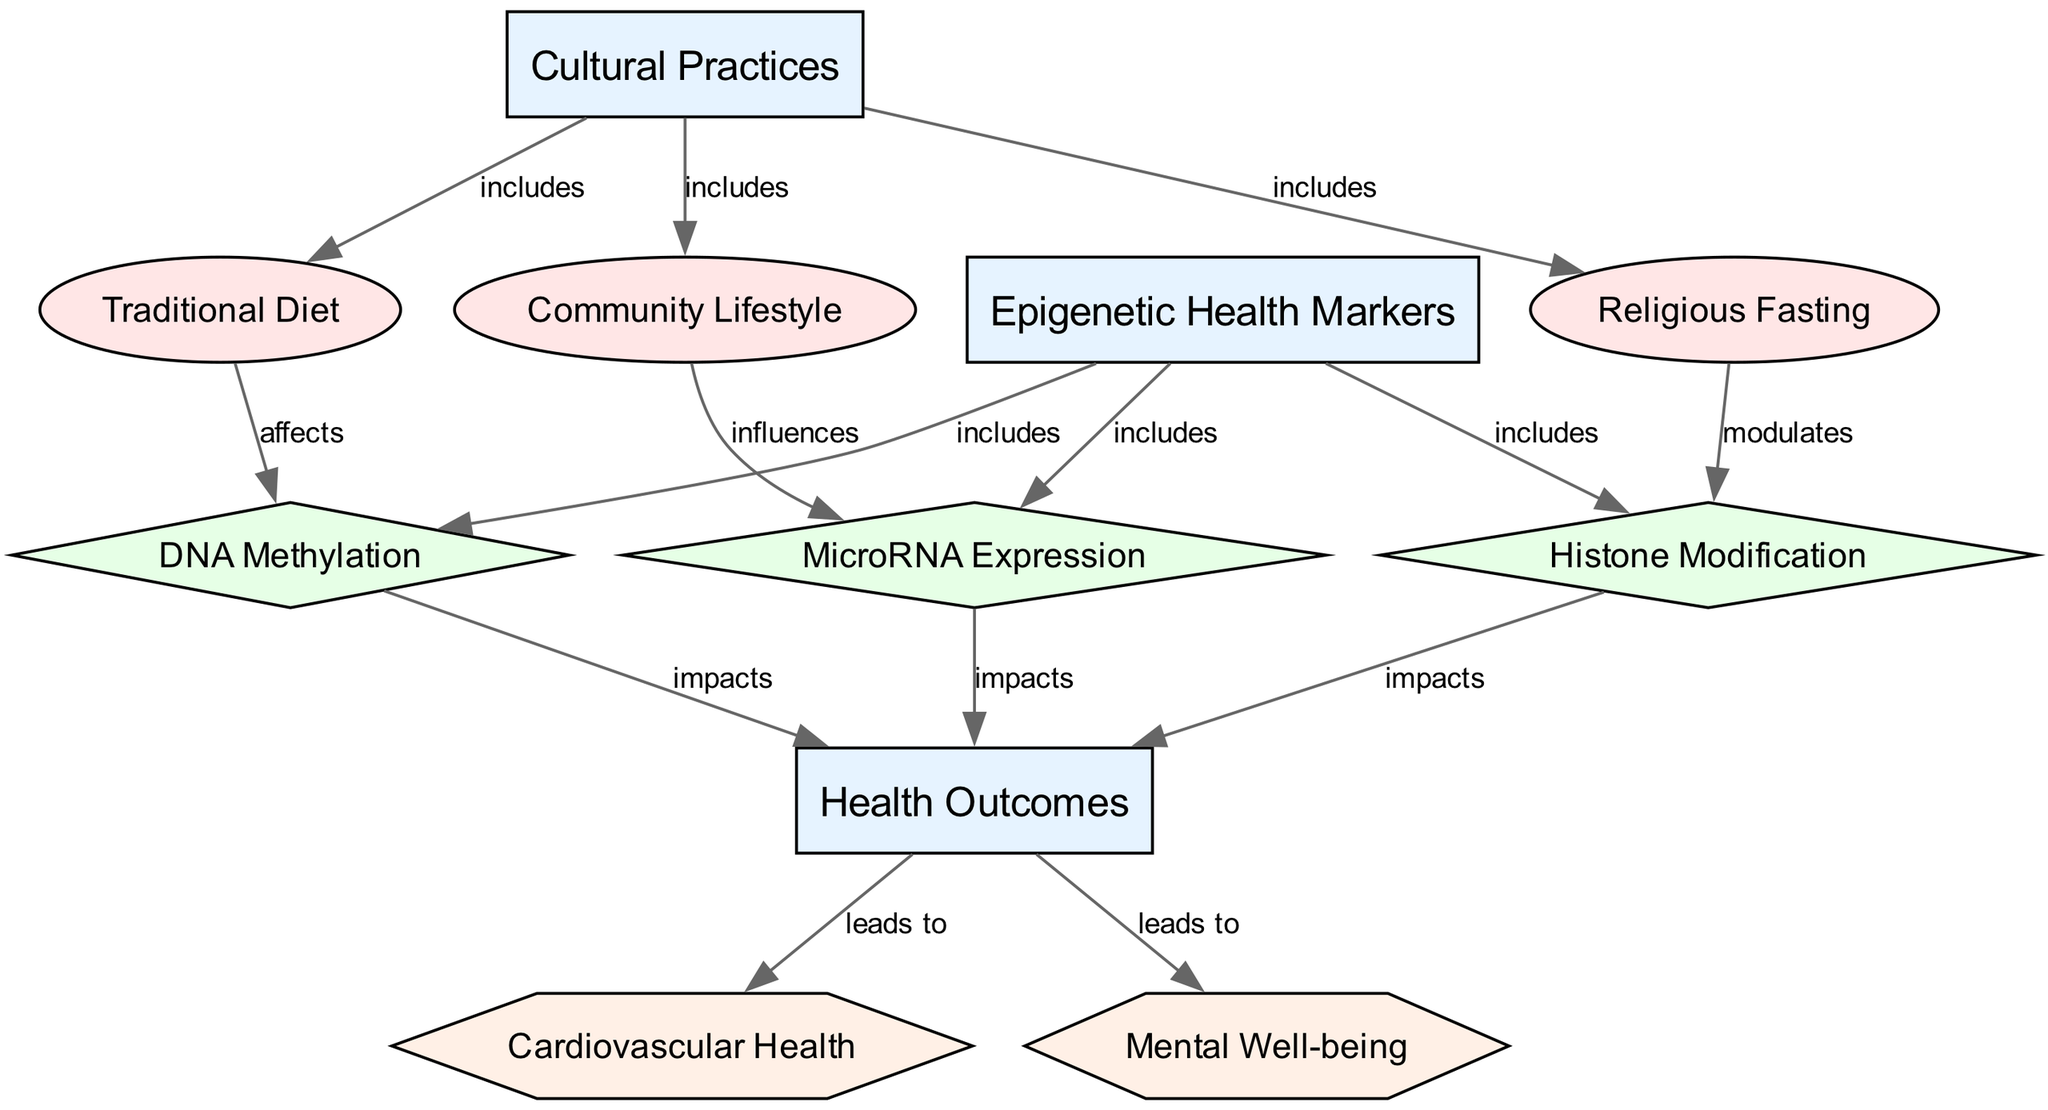What are the three cultural practices listed in the diagram? The diagram identifies three practices under "Cultural Practices": Traditional Diet, Religious Fasting, and Community Lifestyle.
Answer: Traditional Diet, Religious Fasting, Community Lifestyle How many types of epigenetic health markers are represented? There are three types of epigenetic health markers shown in the diagram: DNA Methylation, Histone Modification, and MicroRNA Expression.
Answer: 3 Which cultural practice affects DNA methylation? According to the diagram, the Traditional Diet is the cultural practice that affects DNA methylation.
Answer: Traditional Diet What are the health outcomes linked to the epigenetic health markers? The diagram shows that the health outcomes linked to the epigenetic health markers are Cardiovascular Health and Mental Well-being.
Answer: Cardiovascular Health, Mental Well-being Which cultural practice modulates histone modification? Religious Fasting is the cultural practice indicated in the diagram that modulates histone modification.
Answer: Religious Fasting What is the relationship between community lifestyle and microRNA expression? The diagram states that the Community Lifestyle influences microRNA expression, indicating a direct relationship.
Answer: influences How many nodes are there in total in the diagram? The diagram presents a total of 11 nodes, encompassing categories, practices, markers, and outcomes.
Answer: 11 Which health outcome is particularly impacted by all three markers? Both health outcomes, Cardiovascular Health and Mental Well-being, are impacted by DNA Methylation, Histone Modification, and MicroRNA Expression, indicating that both are particularly affected.
Answer: Cardiovascular Health, Mental Well-being What is the type of edge that connects cultural practices and epigenetic health markers? The edges connecting the cultural practices to the epigenetic health markers are labeled as "includes," indicating this type of relationship between them.
Answer: includes 